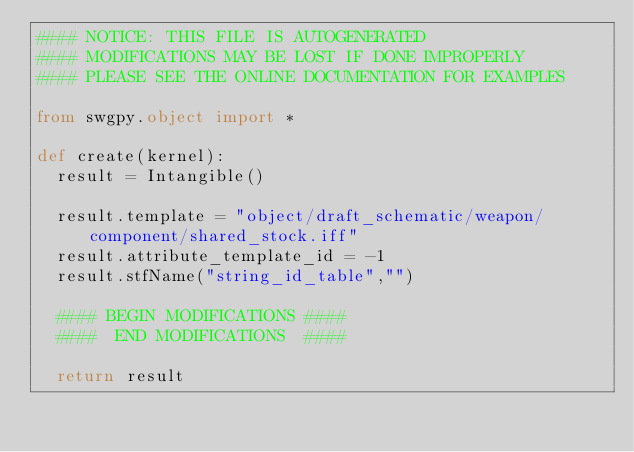<code> <loc_0><loc_0><loc_500><loc_500><_Python_>#### NOTICE: THIS FILE IS AUTOGENERATED
#### MODIFICATIONS MAY BE LOST IF DONE IMPROPERLY
#### PLEASE SEE THE ONLINE DOCUMENTATION FOR EXAMPLES

from swgpy.object import *	

def create(kernel):
	result = Intangible()

	result.template = "object/draft_schematic/weapon/component/shared_stock.iff"
	result.attribute_template_id = -1
	result.stfName("string_id_table","")		
	
	#### BEGIN MODIFICATIONS ####
	####  END MODIFICATIONS  ####
	
	return result</code> 